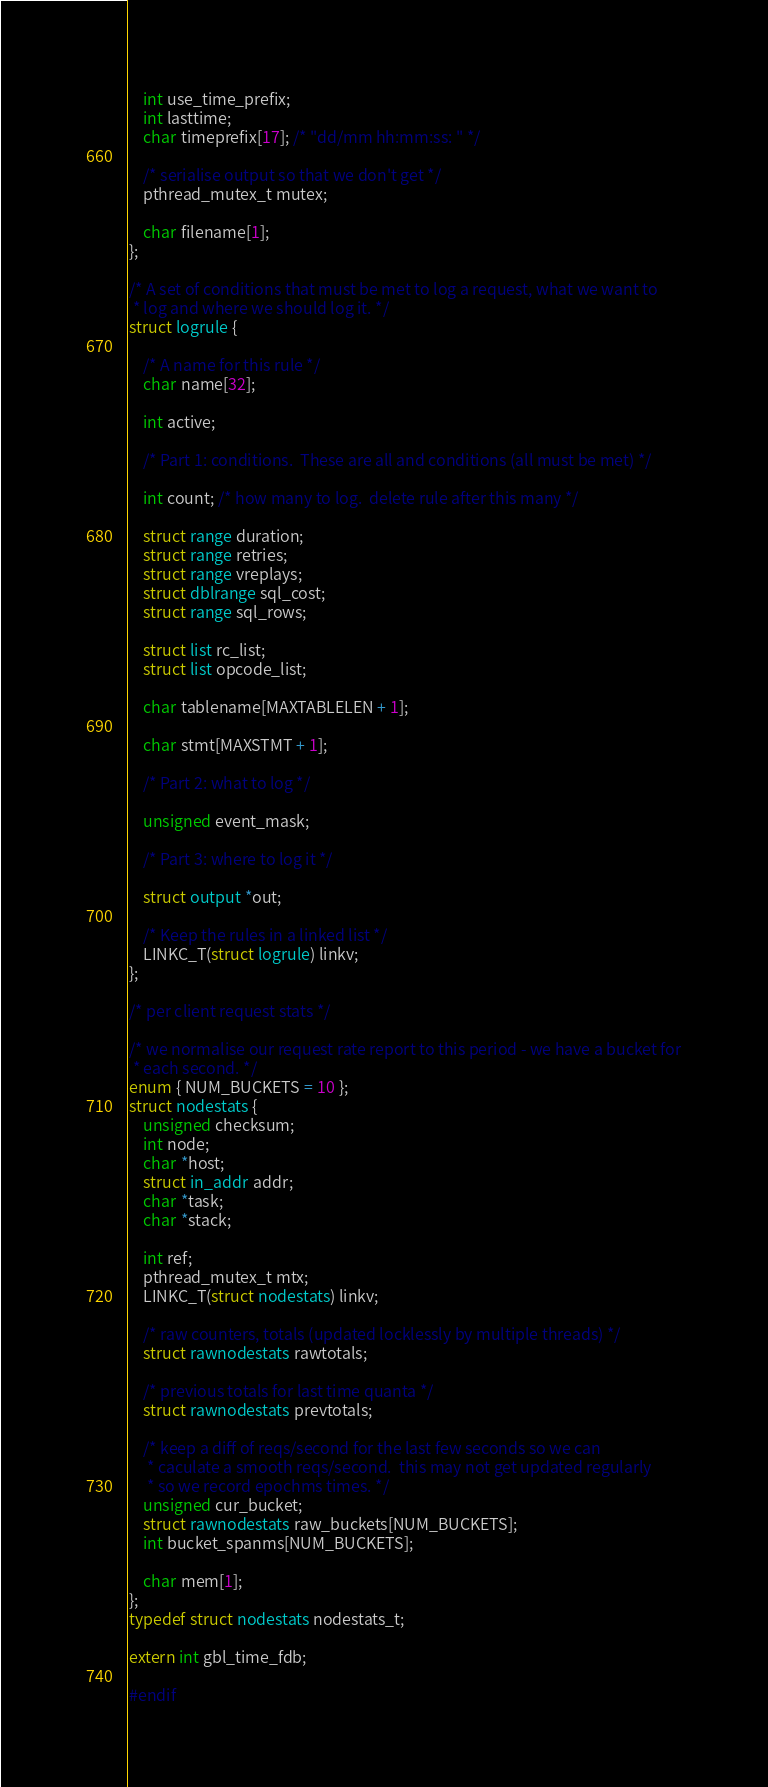<code> <loc_0><loc_0><loc_500><loc_500><_C_>    int use_time_prefix;
    int lasttime;
    char timeprefix[17]; /* "dd/mm hh:mm:ss: " */

    /* serialise output so that we don't get */
    pthread_mutex_t mutex;

    char filename[1];
};

/* A set of conditions that must be met to log a request, what we want to
 * log and where we should log it. */
struct logrule {

    /* A name for this rule */
    char name[32];

    int active;

    /* Part 1: conditions.  These are all and conditions (all must be met) */

    int count; /* how many to log.  delete rule after this many */

    struct range duration;
    struct range retries;
    struct range vreplays;
    struct dblrange sql_cost;
    struct range sql_rows;

    struct list rc_list;
    struct list opcode_list;

    char tablename[MAXTABLELEN + 1];

    char stmt[MAXSTMT + 1];

    /* Part 2: what to log */

    unsigned event_mask;

    /* Part 3: where to log it */

    struct output *out;

    /* Keep the rules in a linked list */
    LINKC_T(struct logrule) linkv;
};

/* per client request stats */

/* we normalise our request rate report to this period - we have a bucket for
 * each second. */
enum { NUM_BUCKETS = 10 };
struct nodestats {
    unsigned checksum;
    int node;
    char *host;
    struct in_addr addr;
    char *task;
    char *stack;

    int ref;
    pthread_mutex_t mtx;
    LINKC_T(struct nodestats) linkv;

    /* raw counters, totals (updated locklessly by multiple threads) */
    struct rawnodestats rawtotals;

    /* previous totals for last time quanta */
    struct rawnodestats prevtotals;

    /* keep a diff of reqs/second for the last few seconds so we can
     * caculate a smooth reqs/second.  this may not get updated regularly
     * so we record epochms times. */
    unsigned cur_bucket;
    struct rawnodestats raw_buckets[NUM_BUCKETS];
    int bucket_spanms[NUM_BUCKETS];

    char mem[1];
};
typedef struct nodestats nodestats_t;

extern int gbl_time_fdb;

#endif
</code> 